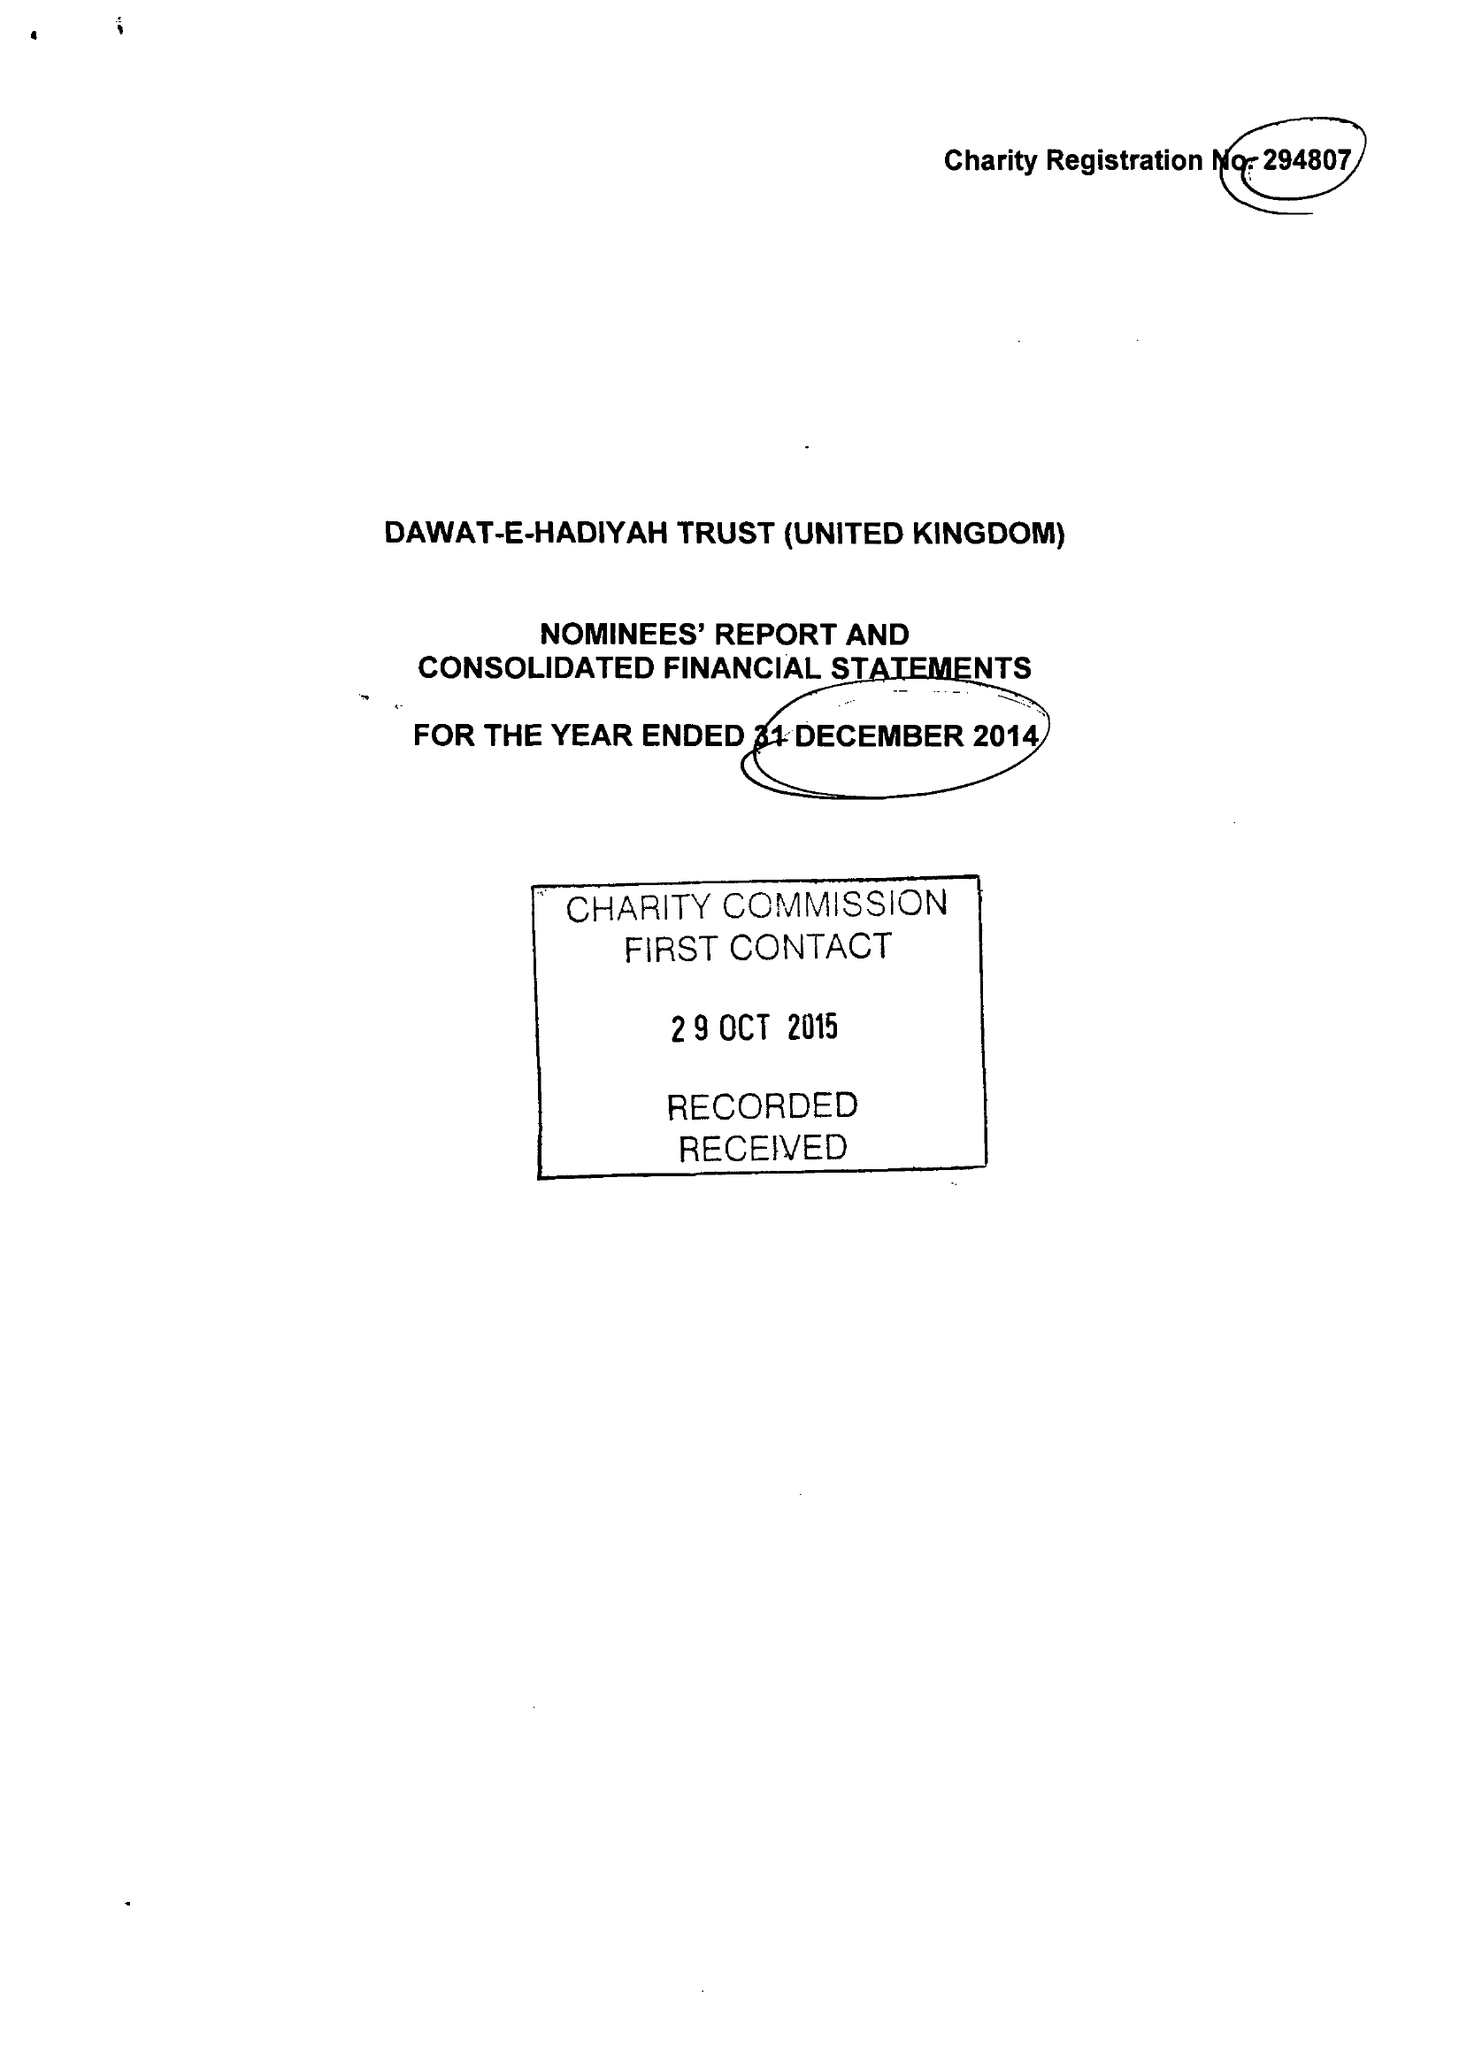What is the value for the spending_annually_in_british_pounds?
Answer the question using a single word or phrase. 5664243.00 